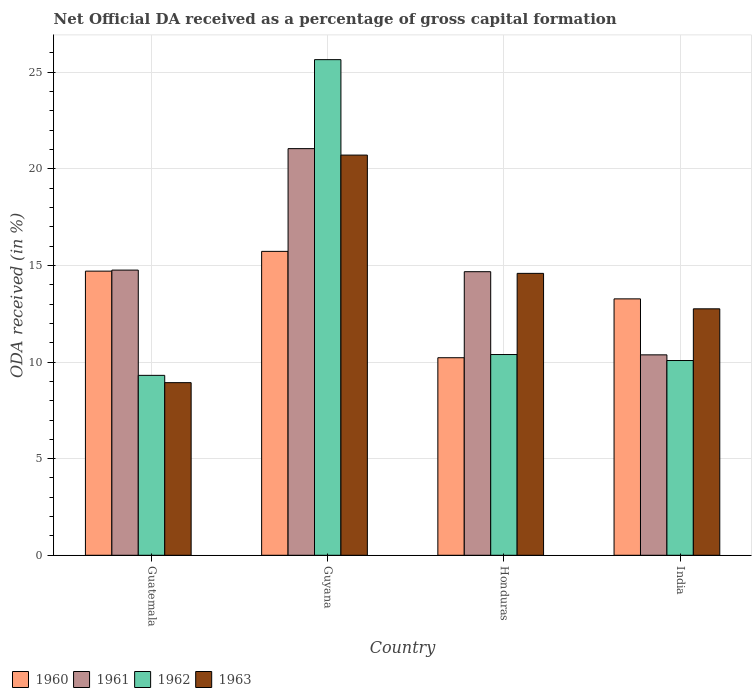How many different coloured bars are there?
Ensure brevity in your answer.  4. Are the number of bars per tick equal to the number of legend labels?
Offer a very short reply. Yes. Are the number of bars on each tick of the X-axis equal?
Your answer should be very brief. Yes. How many bars are there on the 1st tick from the left?
Ensure brevity in your answer.  4. What is the label of the 3rd group of bars from the left?
Provide a short and direct response. Honduras. What is the net ODA received in 1960 in Honduras?
Ensure brevity in your answer.  10.23. Across all countries, what is the maximum net ODA received in 1960?
Offer a terse response. 15.73. Across all countries, what is the minimum net ODA received in 1963?
Offer a terse response. 8.93. In which country was the net ODA received in 1960 maximum?
Ensure brevity in your answer.  Guyana. In which country was the net ODA received in 1962 minimum?
Offer a terse response. Guatemala. What is the total net ODA received in 1962 in the graph?
Give a very brief answer. 55.44. What is the difference between the net ODA received in 1961 in Guyana and that in India?
Provide a succinct answer. 10.67. What is the difference between the net ODA received in 1963 in India and the net ODA received in 1961 in Guyana?
Your answer should be compact. -8.29. What is the average net ODA received in 1963 per country?
Your response must be concise. 14.25. What is the difference between the net ODA received of/in 1962 and net ODA received of/in 1963 in India?
Your answer should be very brief. -2.68. What is the ratio of the net ODA received in 1961 in Guyana to that in Honduras?
Provide a short and direct response. 1.43. Is the difference between the net ODA received in 1962 in Guatemala and Guyana greater than the difference between the net ODA received in 1963 in Guatemala and Guyana?
Keep it short and to the point. No. What is the difference between the highest and the second highest net ODA received in 1961?
Keep it short and to the point. 6.29. What is the difference between the highest and the lowest net ODA received in 1960?
Give a very brief answer. 5.5. In how many countries, is the net ODA received in 1960 greater than the average net ODA received in 1960 taken over all countries?
Provide a short and direct response. 2. What does the 2nd bar from the left in Honduras represents?
Your answer should be very brief. 1961. What does the 3rd bar from the right in Guyana represents?
Your answer should be compact. 1961. How many bars are there?
Offer a very short reply. 16. What is the difference between two consecutive major ticks on the Y-axis?
Ensure brevity in your answer.  5. Are the values on the major ticks of Y-axis written in scientific E-notation?
Keep it short and to the point. No. How many legend labels are there?
Offer a very short reply. 4. How are the legend labels stacked?
Your answer should be compact. Horizontal. What is the title of the graph?
Your response must be concise. Net Official DA received as a percentage of gross capital formation. What is the label or title of the X-axis?
Offer a terse response. Country. What is the label or title of the Y-axis?
Offer a very short reply. ODA received (in %). What is the ODA received (in %) of 1960 in Guatemala?
Provide a succinct answer. 14.71. What is the ODA received (in %) of 1961 in Guatemala?
Provide a short and direct response. 14.76. What is the ODA received (in %) of 1962 in Guatemala?
Give a very brief answer. 9.31. What is the ODA received (in %) in 1963 in Guatemala?
Give a very brief answer. 8.93. What is the ODA received (in %) in 1960 in Guyana?
Your answer should be very brief. 15.73. What is the ODA received (in %) of 1961 in Guyana?
Your response must be concise. 21.05. What is the ODA received (in %) in 1962 in Guyana?
Your answer should be compact. 25.65. What is the ODA received (in %) of 1963 in Guyana?
Your answer should be compact. 20.71. What is the ODA received (in %) of 1960 in Honduras?
Ensure brevity in your answer.  10.23. What is the ODA received (in %) in 1961 in Honduras?
Give a very brief answer. 14.68. What is the ODA received (in %) of 1962 in Honduras?
Give a very brief answer. 10.39. What is the ODA received (in %) of 1963 in Honduras?
Offer a terse response. 14.59. What is the ODA received (in %) of 1960 in India?
Your response must be concise. 13.27. What is the ODA received (in %) of 1961 in India?
Ensure brevity in your answer.  10.37. What is the ODA received (in %) in 1962 in India?
Ensure brevity in your answer.  10.08. What is the ODA received (in %) in 1963 in India?
Provide a succinct answer. 12.76. Across all countries, what is the maximum ODA received (in %) of 1960?
Your answer should be very brief. 15.73. Across all countries, what is the maximum ODA received (in %) of 1961?
Offer a very short reply. 21.05. Across all countries, what is the maximum ODA received (in %) in 1962?
Provide a short and direct response. 25.65. Across all countries, what is the maximum ODA received (in %) in 1963?
Your answer should be compact. 20.71. Across all countries, what is the minimum ODA received (in %) in 1960?
Your response must be concise. 10.23. Across all countries, what is the minimum ODA received (in %) of 1961?
Your answer should be very brief. 10.37. Across all countries, what is the minimum ODA received (in %) in 1962?
Offer a very short reply. 9.31. Across all countries, what is the minimum ODA received (in %) of 1963?
Your answer should be compact. 8.93. What is the total ODA received (in %) in 1960 in the graph?
Offer a very short reply. 53.93. What is the total ODA received (in %) in 1961 in the graph?
Ensure brevity in your answer.  60.86. What is the total ODA received (in %) in 1962 in the graph?
Provide a short and direct response. 55.44. What is the total ODA received (in %) of 1963 in the graph?
Your response must be concise. 56.99. What is the difference between the ODA received (in %) of 1960 in Guatemala and that in Guyana?
Give a very brief answer. -1.02. What is the difference between the ODA received (in %) of 1961 in Guatemala and that in Guyana?
Ensure brevity in your answer.  -6.29. What is the difference between the ODA received (in %) of 1962 in Guatemala and that in Guyana?
Provide a succinct answer. -16.34. What is the difference between the ODA received (in %) in 1963 in Guatemala and that in Guyana?
Your answer should be very brief. -11.78. What is the difference between the ODA received (in %) of 1960 in Guatemala and that in Honduras?
Provide a succinct answer. 4.48. What is the difference between the ODA received (in %) in 1961 in Guatemala and that in Honduras?
Your answer should be very brief. 0.08. What is the difference between the ODA received (in %) in 1962 in Guatemala and that in Honduras?
Your answer should be compact. -1.08. What is the difference between the ODA received (in %) in 1963 in Guatemala and that in Honduras?
Ensure brevity in your answer.  -5.66. What is the difference between the ODA received (in %) of 1960 in Guatemala and that in India?
Your answer should be compact. 1.44. What is the difference between the ODA received (in %) in 1961 in Guatemala and that in India?
Provide a succinct answer. 4.39. What is the difference between the ODA received (in %) in 1962 in Guatemala and that in India?
Provide a short and direct response. -0.77. What is the difference between the ODA received (in %) in 1963 in Guatemala and that in India?
Offer a very short reply. -3.82. What is the difference between the ODA received (in %) in 1960 in Guyana and that in Honduras?
Your answer should be very brief. 5.5. What is the difference between the ODA received (in %) in 1961 in Guyana and that in Honduras?
Offer a terse response. 6.37. What is the difference between the ODA received (in %) in 1962 in Guyana and that in Honduras?
Your answer should be compact. 15.26. What is the difference between the ODA received (in %) of 1963 in Guyana and that in Honduras?
Offer a terse response. 6.12. What is the difference between the ODA received (in %) of 1960 in Guyana and that in India?
Provide a short and direct response. 2.46. What is the difference between the ODA received (in %) in 1961 in Guyana and that in India?
Offer a very short reply. 10.67. What is the difference between the ODA received (in %) in 1962 in Guyana and that in India?
Provide a succinct answer. 15.57. What is the difference between the ODA received (in %) in 1963 in Guyana and that in India?
Your response must be concise. 7.96. What is the difference between the ODA received (in %) in 1960 in Honduras and that in India?
Make the answer very short. -3.05. What is the difference between the ODA received (in %) in 1961 in Honduras and that in India?
Offer a terse response. 4.3. What is the difference between the ODA received (in %) in 1962 in Honduras and that in India?
Your answer should be compact. 0.31. What is the difference between the ODA received (in %) of 1963 in Honduras and that in India?
Offer a very short reply. 1.84. What is the difference between the ODA received (in %) in 1960 in Guatemala and the ODA received (in %) in 1961 in Guyana?
Ensure brevity in your answer.  -6.34. What is the difference between the ODA received (in %) of 1960 in Guatemala and the ODA received (in %) of 1962 in Guyana?
Your answer should be compact. -10.95. What is the difference between the ODA received (in %) of 1960 in Guatemala and the ODA received (in %) of 1963 in Guyana?
Provide a short and direct response. -6.01. What is the difference between the ODA received (in %) in 1961 in Guatemala and the ODA received (in %) in 1962 in Guyana?
Offer a very short reply. -10.89. What is the difference between the ODA received (in %) in 1961 in Guatemala and the ODA received (in %) in 1963 in Guyana?
Provide a succinct answer. -5.95. What is the difference between the ODA received (in %) in 1962 in Guatemala and the ODA received (in %) in 1963 in Guyana?
Make the answer very short. -11.4. What is the difference between the ODA received (in %) in 1960 in Guatemala and the ODA received (in %) in 1961 in Honduras?
Make the answer very short. 0.03. What is the difference between the ODA received (in %) of 1960 in Guatemala and the ODA received (in %) of 1962 in Honduras?
Offer a very short reply. 4.32. What is the difference between the ODA received (in %) of 1960 in Guatemala and the ODA received (in %) of 1963 in Honduras?
Provide a short and direct response. 0.12. What is the difference between the ODA received (in %) in 1961 in Guatemala and the ODA received (in %) in 1962 in Honduras?
Your answer should be very brief. 4.37. What is the difference between the ODA received (in %) in 1961 in Guatemala and the ODA received (in %) in 1963 in Honduras?
Your answer should be compact. 0.17. What is the difference between the ODA received (in %) in 1962 in Guatemala and the ODA received (in %) in 1963 in Honduras?
Your response must be concise. -5.28. What is the difference between the ODA received (in %) of 1960 in Guatemala and the ODA received (in %) of 1961 in India?
Provide a succinct answer. 4.33. What is the difference between the ODA received (in %) of 1960 in Guatemala and the ODA received (in %) of 1962 in India?
Offer a very short reply. 4.63. What is the difference between the ODA received (in %) of 1960 in Guatemala and the ODA received (in %) of 1963 in India?
Your answer should be compact. 1.95. What is the difference between the ODA received (in %) of 1961 in Guatemala and the ODA received (in %) of 1962 in India?
Provide a short and direct response. 4.68. What is the difference between the ODA received (in %) in 1961 in Guatemala and the ODA received (in %) in 1963 in India?
Offer a terse response. 2. What is the difference between the ODA received (in %) in 1962 in Guatemala and the ODA received (in %) in 1963 in India?
Keep it short and to the point. -3.44. What is the difference between the ODA received (in %) of 1960 in Guyana and the ODA received (in %) of 1961 in Honduras?
Offer a very short reply. 1.05. What is the difference between the ODA received (in %) of 1960 in Guyana and the ODA received (in %) of 1962 in Honduras?
Your answer should be very brief. 5.34. What is the difference between the ODA received (in %) of 1960 in Guyana and the ODA received (in %) of 1963 in Honduras?
Ensure brevity in your answer.  1.14. What is the difference between the ODA received (in %) in 1961 in Guyana and the ODA received (in %) in 1962 in Honduras?
Your answer should be very brief. 10.66. What is the difference between the ODA received (in %) in 1961 in Guyana and the ODA received (in %) in 1963 in Honduras?
Your answer should be very brief. 6.46. What is the difference between the ODA received (in %) in 1962 in Guyana and the ODA received (in %) in 1963 in Honduras?
Offer a terse response. 11.06. What is the difference between the ODA received (in %) in 1960 in Guyana and the ODA received (in %) in 1961 in India?
Offer a terse response. 5.36. What is the difference between the ODA received (in %) in 1960 in Guyana and the ODA received (in %) in 1962 in India?
Offer a terse response. 5.65. What is the difference between the ODA received (in %) in 1960 in Guyana and the ODA received (in %) in 1963 in India?
Provide a short and direct response. 2.97. What is the difference between the ODA received (in %) in 1961 in Guyana and the ODA received (in %) in 1962 in India?
Keep it short and to the point. 10.97. What is the difference between the ODA received (in %) in 1961 in Guyana and the ODA received (in %) in 1963 in India?
Offer a very short reply. 8.29. What is the difference between the ODA received (in %) of 1962 in Guyana and the ODA received (in %) of 1963 in India?
Offer a terse response. 12.9. What is the difference between the ODA received (in %) of 1960 in Honduras and the ODA received (in %) of 1961 in India?
Give a very brief answer. -0.15. What is the difference between the ODA received (in %) in 1960 in Honduras and the ODA received (in %) in 1962 in India?
Give a very brief answer. 0.14. What is the difference between the ODA received (in %) of 1960 in Honduras and the ODA received (in %) of 1963 in India?
Offer a very short reply. -2.53. What is the difference between the ODA received (in %) of 1961 in Honduras and the ODA received (in %) of 1962 in India?
Provide a succinct answer. 4.6. What is the difference between the ODA received (in %) of 1961 in Honduras and the ODA received (in %) of 1963 in India?
Offer a very short reply. 1.92. What is the difference between the ODA received (in %) in 1962 in Honduras and the ODA received (in %) in 1963 in India?
Keep it short and to the point. -2.37. What is the average ODA received (in %) of 1960 per country?
Keep it short and to the point. 13.48. What is the average ODA received (in %) in 1961 per country?
Your response must be concise. 15.21. What is the average ODA received (in %) in 1962 per country?
Give a very brief answer. 13.86. What is the average ODA received (in %) of 1963 per country?
Your answer should be very brief. 14.25. What is the difference between the ODA received (in %) of 1960 and ODA received (in %) of 1961 in Guatemala?
Make the answer very short. -0.05. What is the difference between the ODA received (in %) of 1960 and ODA received (in %) of 1962 in Guatemala?
Provide a succinct answer. 5.39. What is the difference between the ODA received (in %) of 1960 and ODA received (in %) of 1963 in Guatemala?
Ensure brevity in your answer.  5.77. What is the difference between the ODA received (in %) in 1961 and ODA received (in %) in 1962 in Guatemala?
Keep it short and to the point. 5.45. What is the difference between the ODA received (in %) in 1961 and ODA received (in %) in 1963 in Guatemala?
Provide a succinct answer. 5.83. What is the difference between the ODA received (in %) of 1962 and ODA received (in %) of 1963 in Guatemala?
Your answer should be compact. 0.38. What is the difference between the ODA received (in %) of 1960 and ODA received (in %) of 1961 in Guyana?
Offer a terse response. -5.32. What is the difference between the ODA received (in %) in 1960 and ODA received (in %) in 1962 in Guyana?
Your answer should be very brief. -9.92. What is the difference between the ODA received (in %) in 1960 and ODA received (in %) in 1963 in Guyana?
Your response must be concise. -4.98. What is the difference between the ODA received (in %) in 1961 and ODA received (in %) in 1962 in Guyana?
Make the answer very short. -4.61. What is the difference between the ODA received (in %) of 1961 and ODA received (in %) of 1963 in Guyana?
Your response must be concise. 0.33. What is the difference between the ODA received (in %) in 1962 and ODA received (in %) in 1963 in Guyana?
Offer a terse response. 4.94. What is the difference between the ODA received (in %) in 1960 and ODA received (in %) in 1961 in Honduras?
Make the answer very short. -4.45. What is the difference between the ODA received (in %) of 1960 and ODA received (in %) of 1962 in Honduras?
Your answer should be very brief. -0.16. What is the difference between the ODA received (in %) of 1960 and ODA received (in %) of 1963 in Honduras?
Give a very brief answer. -4.37. What is the difference between the ODA received (in %) in 1961 and ODA received (in %) in 1962 in Honduras?
Your response must be concise. 4.29. What is the difference between the ODA received (in %) in 1961 and ODA received (in %) in 1963 in Honduras?
Your answer should be compact. 0.09. What is the difference between the ODA received (in %) in 1962 and ODA received (in %) in 1963 in Honduras?
Keep it short and to the point. -4.2. What is the difference between the ODA received (in %) in 1960 and ODA received (in %) in 1961 in India?
Provide a short and direct response. 2.9. What is the difference between the ODA received (in %) in 1960 and ODA received (in %) in 1962 in India?
Ensure brevity in your answer.  3.19. What is the difference between the ODA received (in %) of 1960 and ODA received (in %) of 1963 in India?
Your response must be concise. 0.52. What is the difference between the ODA received (in %) in 1961 and ODA received (in %) in 1962 in India?
Provide a succinct answer. 0.29. What is the difference between the ODA received (in %) of 1961 and ODA received (in %) of 1963 in India?
Make the answer very short. -2.38. What is the difference between the ODA received (in %) of 1962 and ODA received (in %) of 1963 in India?
Your response must be concise. -2.68. What is the ratio of the ODA received (in %) in 1960 in Guatemala to that in Guyana?
Offer a very short reply. 0.94. What is the ratio of the ODA received (in %) of 1961 in Guatemala to that in Guyana?
Make the answer very short. 0.7. What is the ratio of the ODA received (in %) in 1962 in Guatemala to that in Guyana?
Offer a very short reply. 0.36. What is the ratio of the ODA received (in %) of 1963 in Guatemala to that in Guyana?
Your answer should be very brief. 0.43. What is the ratio of the ODA received (in %) of 1960 in Guatemala to that in Honduras?
Your answer should be very brief. 1.44. What is the ratio of the ODA received (in %) in 1961 in Guatemala to that in Honduras?
Offer a very short reply. 1.01. What is the ratio of the ODA received (in %) in 1962 in Guatemala to that in Honduras?
Offer a very short reply. 0.9. What is the ratio of the ODA received (in %) of 1963 in Guatemala to that in Honduras?
Your response must be concise. 0.61. What is the ratio of the ODA received (in %) in 1960 in Guatemala to that in India?
Make the answer very short. 1.11. What is the ratio of the ODA received (in %) of 1961 in Guatemala to that in India?
Your response must be concise. 1.42. What is the ratio of the ODA received (in %) of 1962 in Guatemala to that in India?
Provide a short and direct response. 0.92. What is the ratio of the ODA received (in %) of 1963 in Guatemala to that in India?
Give a very brief answer. 0.7. What is the ratio of the ODA received (in %) in 1960 in Guyana to that in Honduras?
Your answer should be very brief. 1.54. What is the ratio of the ODA received (in %) in 1961 in Guyana to that in Honduras?
Ensure brevity in your answer.  1.43. What is the ratio of the ODA received (in %) of 1962 in Guyana to that in Honduras?
Provide a succinct answer. 2.47. What is the ratio of the ODA received (in %) in 1963 in Guyana to that in Honduras?
Your answer should be compact. 1.42. What is the ratio of the ODA received (in %) of 1960 in Guyana to that in India?
Your answer should be very brief. 1.19. What is the ratio of the ODA received (in %) of 1961 in Guyana to that in India?
Your answer should be very brief. 2.03. What is the ratio of the ODA received (in %) in 1962 in Guyana to that in India?
Make the answer very short. 2.54. What is the ratio of the ODA received (in %) in 1963 in Guyana to that in India?
Make the answer very short. 1.62. What is the ratio of the ODA received (in %) of 1960 in Honduras to that in India?
Provide a succinct answer. 0.77. What is the ratio of the ODA received (in %) in 1961 in Honduras to that in India?
Keep it short and to the point. 1.41. What is the ratio of the ODA received (in %) in 1962 in Honduras to that in India?
Give a very brief answer. 1.03. What is the ratio of the ODA received (in %) of 1963 in Honduras to that in India?
Provide a succinct answer. 1.14. What is the difference between the highest and the second highest ODA received (in %) in 1960?
Provide a short and direct response. 1.02. What is the difference between the highest and the second highest ODA received (in %) of 1961?
Ensure brevity in your answer.  6.29. What is the difference between the highest and the second highest ODA received (in %) of 1962?
Your answer should be compact. 15.26. What is the difference between the highest and the second highest ODA received (in %) of 1963?
Make the answer very short. 6.12. What is the difference between the highest and the lowest ODA received (in %) in 1960?
Ensure brevity in your answer.  5.5. What is the difference between the highest and the lowest ODA received (in %) of 1961?
Your response must be concise. 10.67. What is the difference between the highest and the lowest ODA received (in %) of 1962?
Provide a succinct answer. 16.34. What is the difference between the highest and the lowest ODA received (in %) of 1963?
Your answer should be compact. 11.78. 